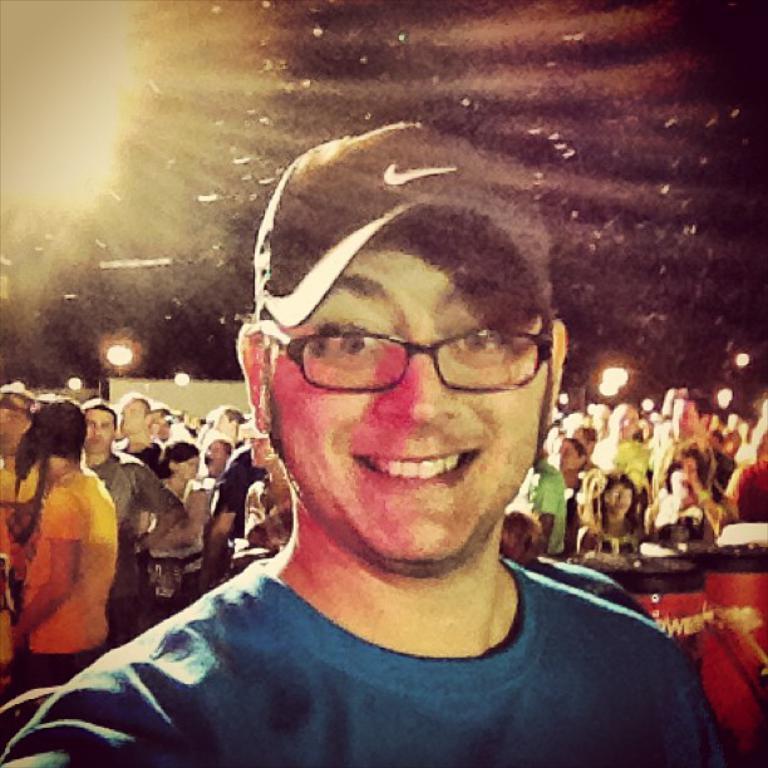In one or two sentences, can you explain what this image depicts? In the center of the image we can see a man smiling. In the background there is crowd and we can see lights. On the right there are drums. 